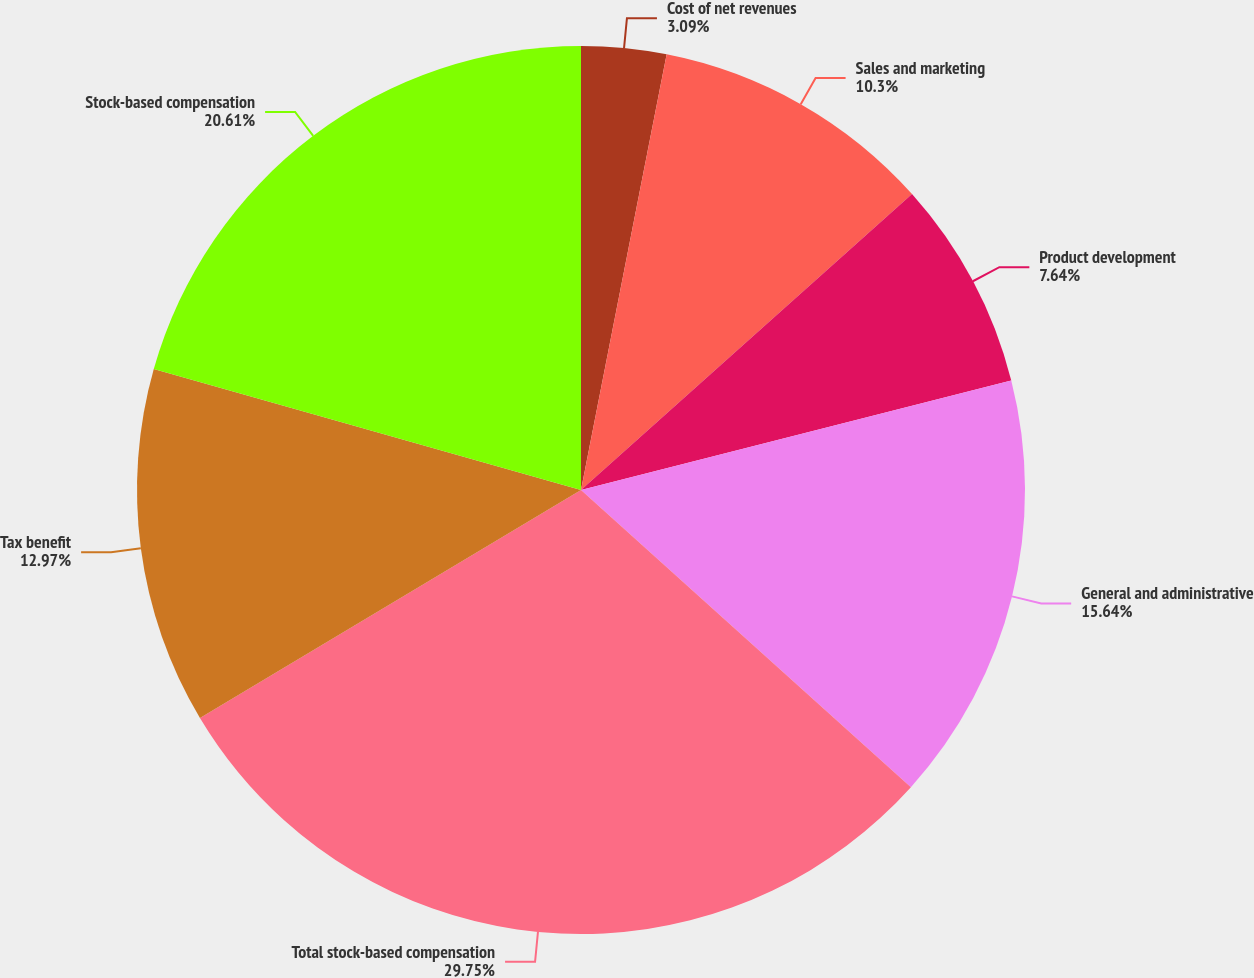Convert chart to OTSL. <chart><loc_0><loc_0><loc_500><loc_500><pie_chart><fcel>Cost of net revenues<fcel>Sales and marketing<fcel>Product development<fcel>General and administrative<fcel>Total stock-based compensation<fcel>Tax benefit<fcel>Stock-based compensation<nl><fcel>3.09%<fcel>10.3%<fcel>7.64%<fcel>15.64%<fcel>29.75%<fcel>12.97%<fcel>20.61%<nl></chart> 